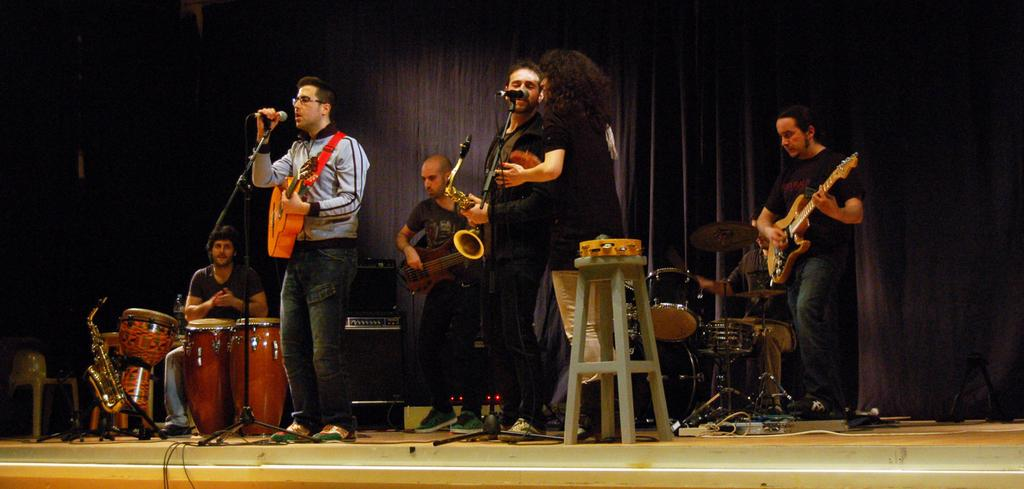What is the man holding in the image? The man is holding a guitar and a microphone. What is the man doing with the microphone? The man is singing in front of the microphone. Are there other musicians in the image? Yes, there are persons playing musical instruments. What is the purpose of the table in the image? The purpose of the table is not specified, but it could be used for holding equipment or other items. What is the curtain used for in the image? The curtain might be used as a backdrop or to create a performance space. Is there a process of rain happening in the image? No, there is no rain or indication of weather in the image. What type of basin is used for the musical instruments in the image? There is no basin present in the image; the musical instruments are being played by the persons in the image. 